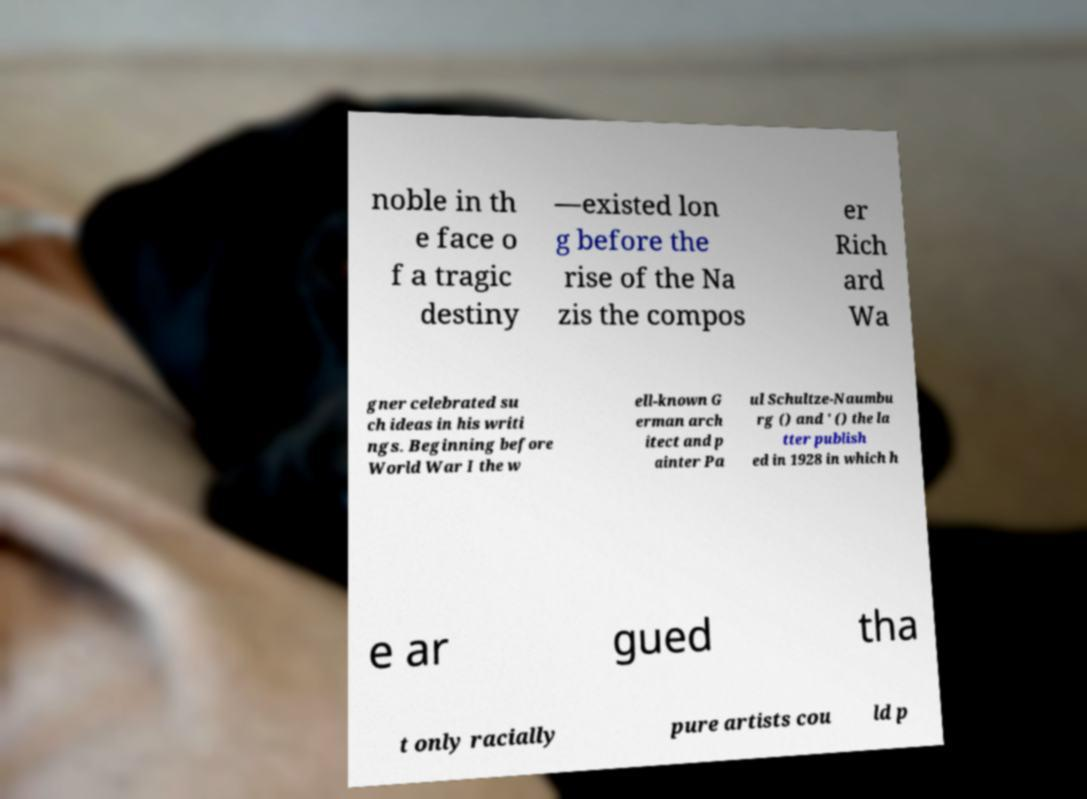I need the written content from this picture converted into text. Can you do that? noble in th e face o f a tragic destiny —existed lon g before the rise of the Na zis the compos er Rich ard Wa gner celebrated su ch ideas in his writi ngs. Beginning before World War I the w ell-known G erman arch itect and p ainter Pa ul Schultze-Naumbu rg () and ' () the la tter publish ed in 1928 in which h e ar gued tha t only racially pure artists cou ld p 